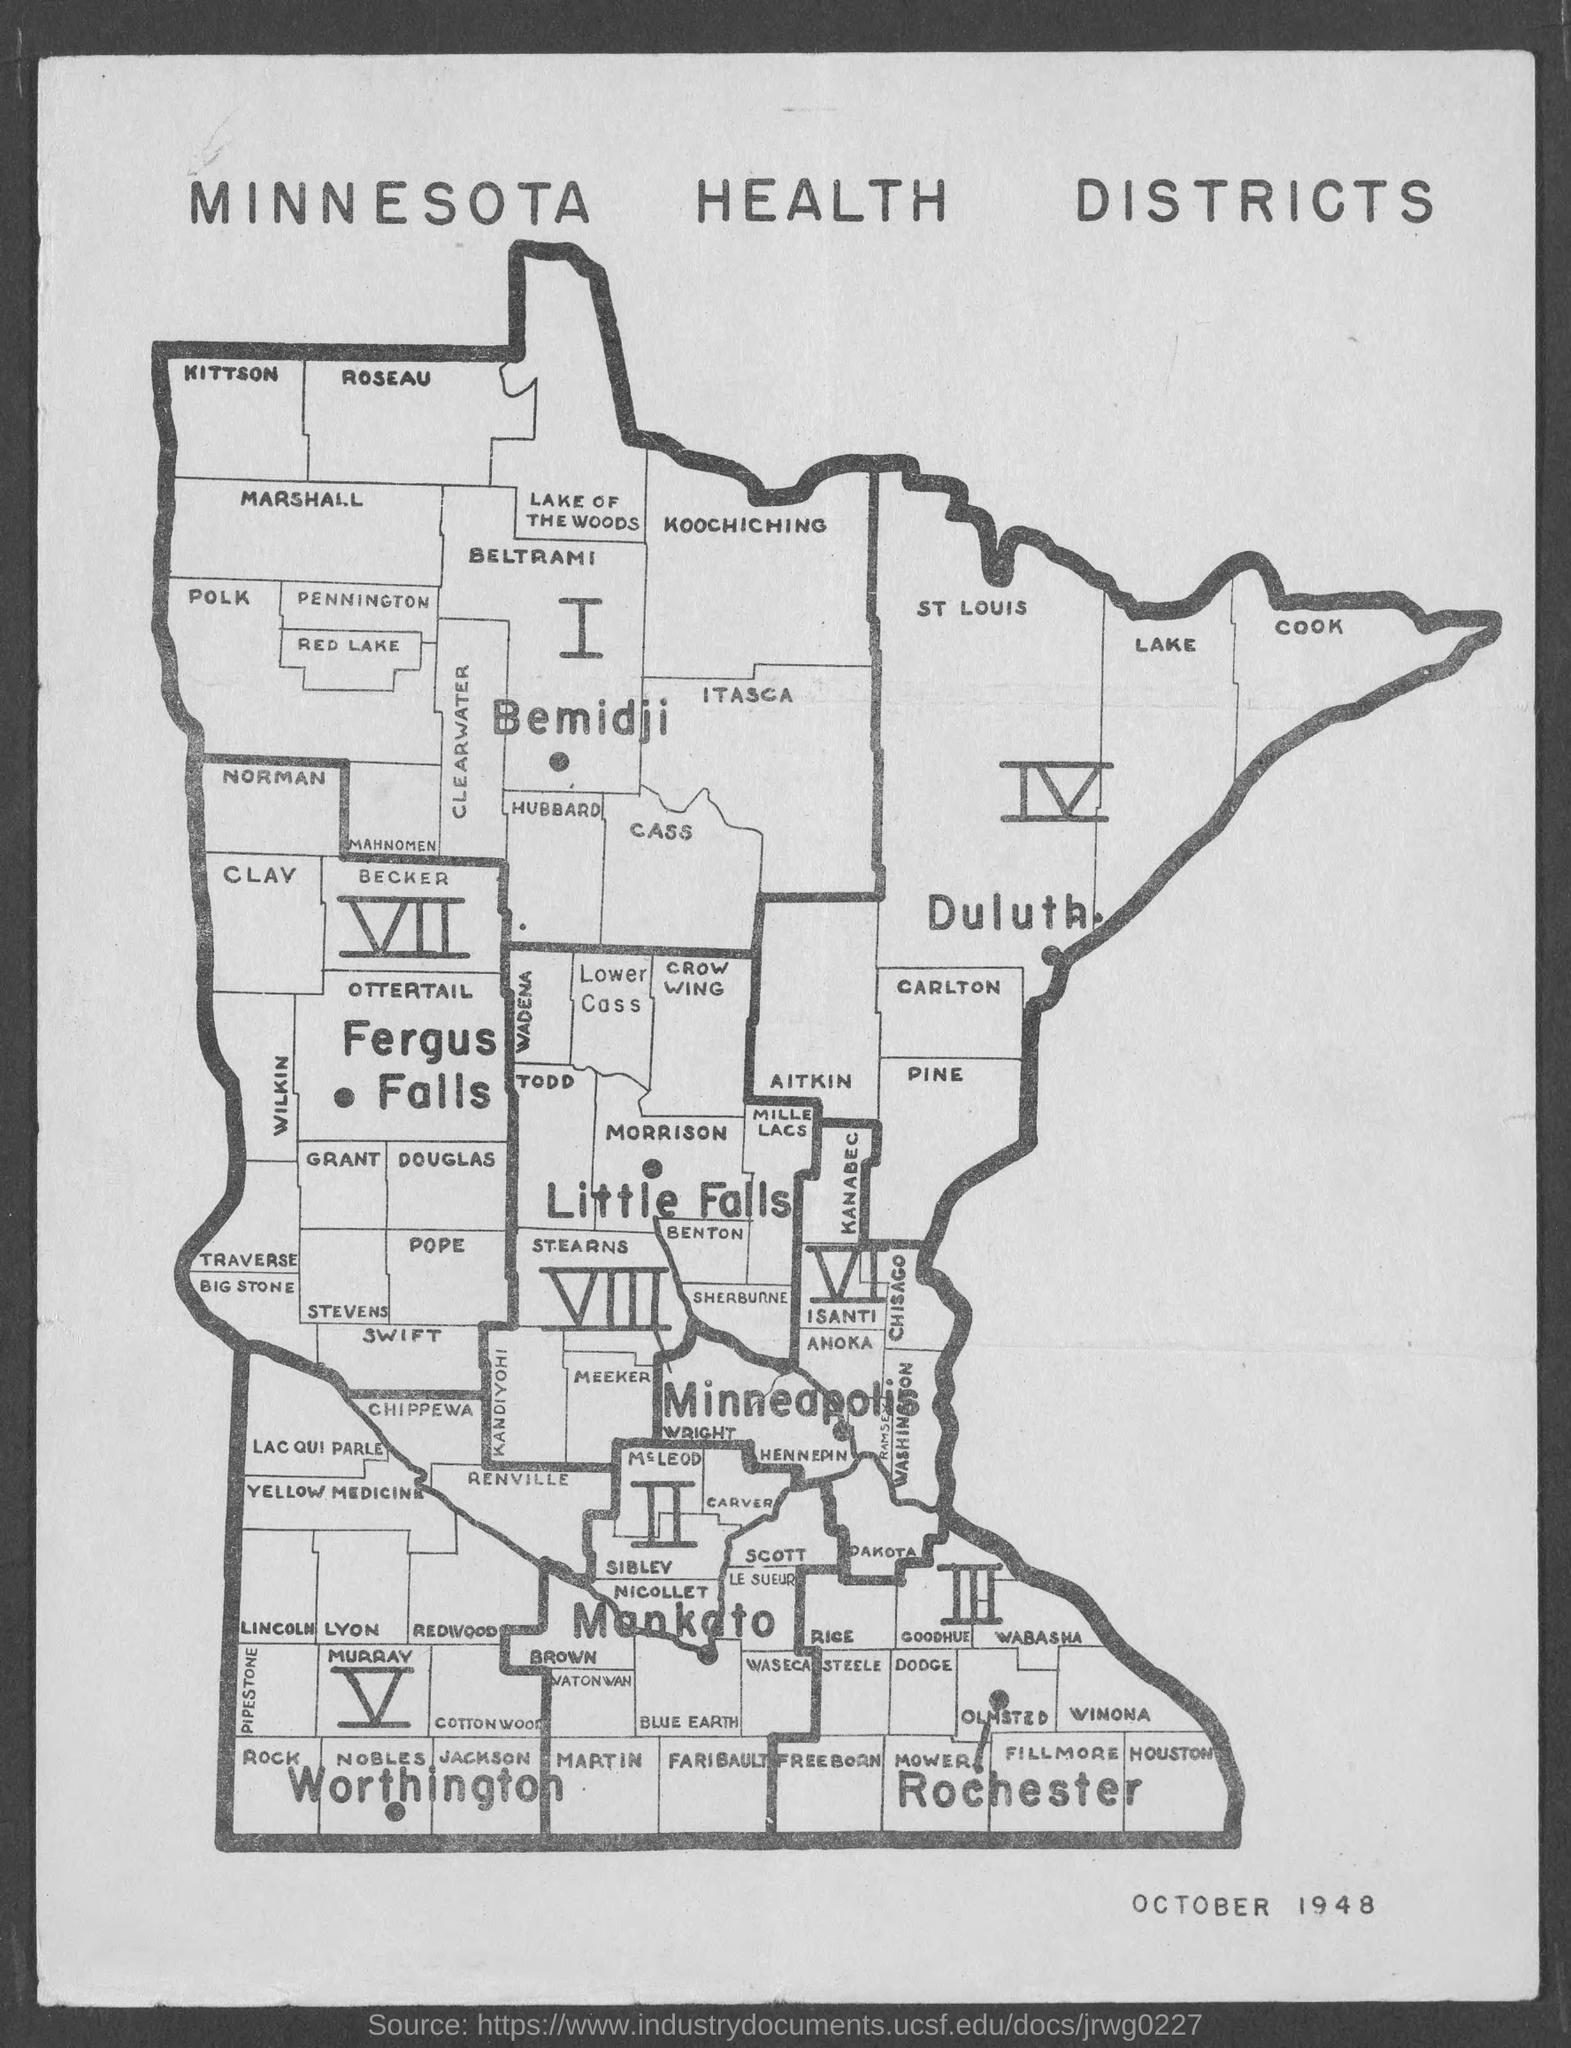List a handful of essential elements in this visual. The month and year mentioned at the bottom of the page is October 1948. What map is it? It is a map of Minnesota health districts. 